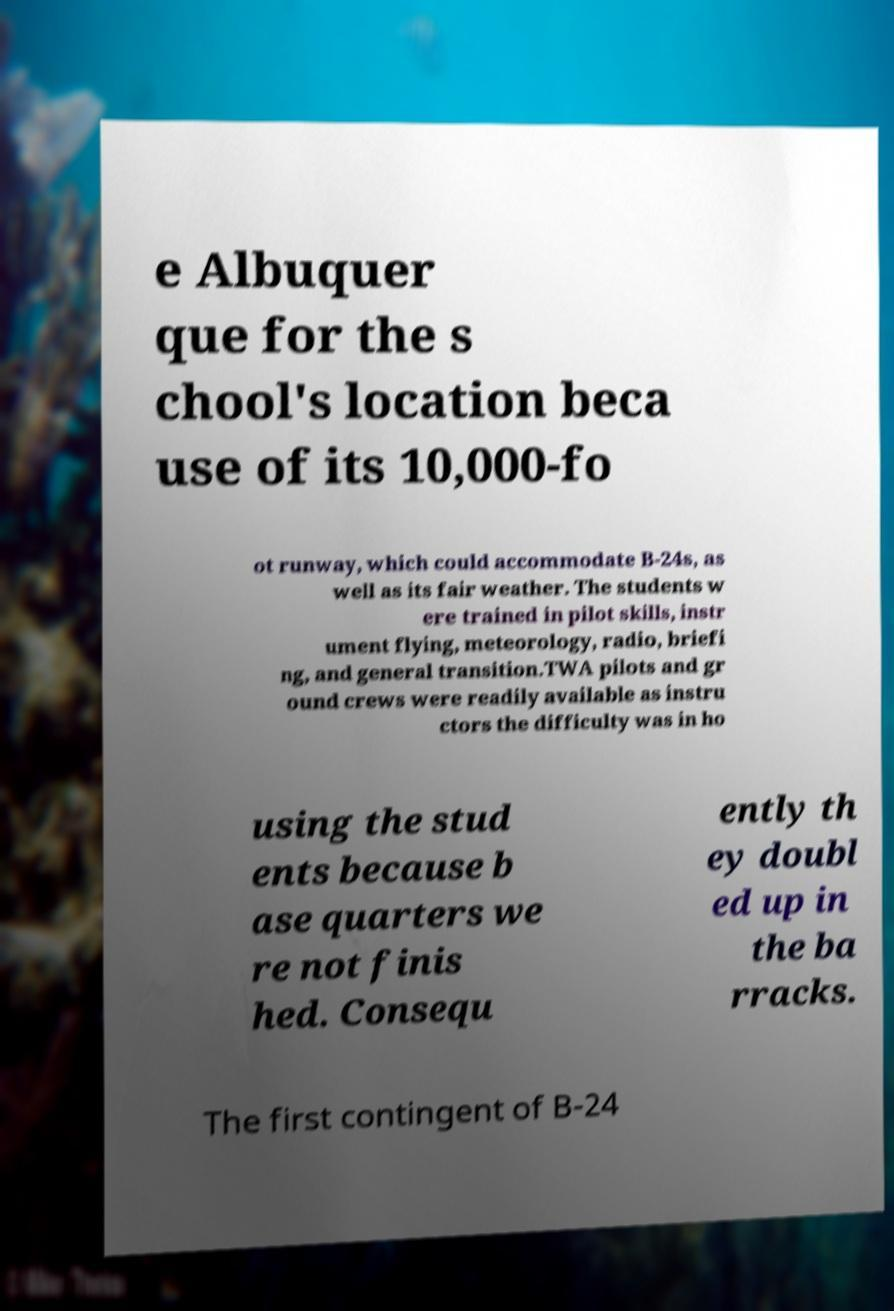I need the written content from this picture converted into text. Can you do that? e Albuquer que for the s chool's location beca use of its 10,000-fo ot runway, which could accommodate B-24s, as well as its fair weather. The students w ere trained in pilot skills, instr ument flying, meteorology, radio, briefi ng, and general transition.TWA pilots and gr ound crews were readily available as instru ctors the difficulty was in ho using the stud ents because b ase quarters we re not finis hed. Consequ ently th ey doubl ed up in the ba rracks. The first contingent of B-24 